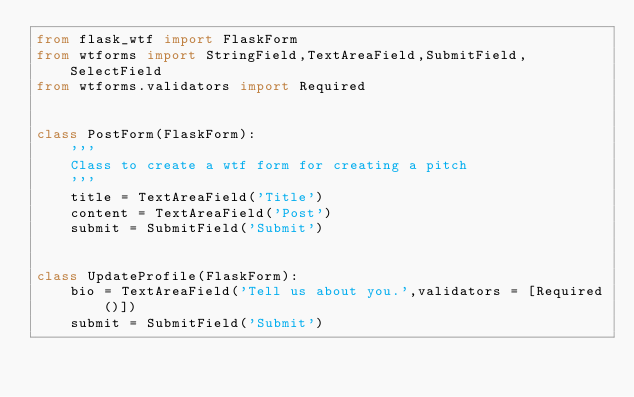<code> <loc_0><loc_0><loc_500><loc_500><_Python_>from flask_wtf import FlaskForm
from wtforms import StringField,TextAreaField,SubmitField,SelectField
from wtforms.validators import Required


class PostForm(FlaskForm):
    '''
    Class to create a wtf form for creating a pitch
    '''
    title = TextAreaField('Title')
    content = TextAreaField('Post')
    submit = SubmitField('Submit')


class UpdateProfile(FlaskForm):
    bio = TextAreaField('Tell us about you.',validators = [Required()])
    submit = SubmitField('Submit')</code> 